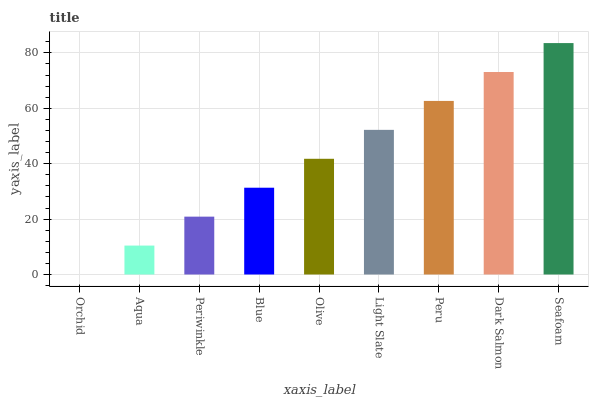Is Aqua the minimum?
Answer yes or no. No. Is Aqua the maximum?
Answer yes or no. No. Is Aqua greater than Orchid?
Answer yes or no. Yes. Is Orchid less than Aqua?
Answer yes or no. Yes. Is Orchid greater than Aqua?
Answer yes or no. No. Is Aqua less than Orchid?
Answer yes or no. No. Is Olive the high median?
Answer yes or no. Yes. Is Olive the low median?
Answer yes or no. Yes. Is Seafoam the high median?
Answer yes or no. No. Is Seafoam the low median?
Answer yes or no. No. 